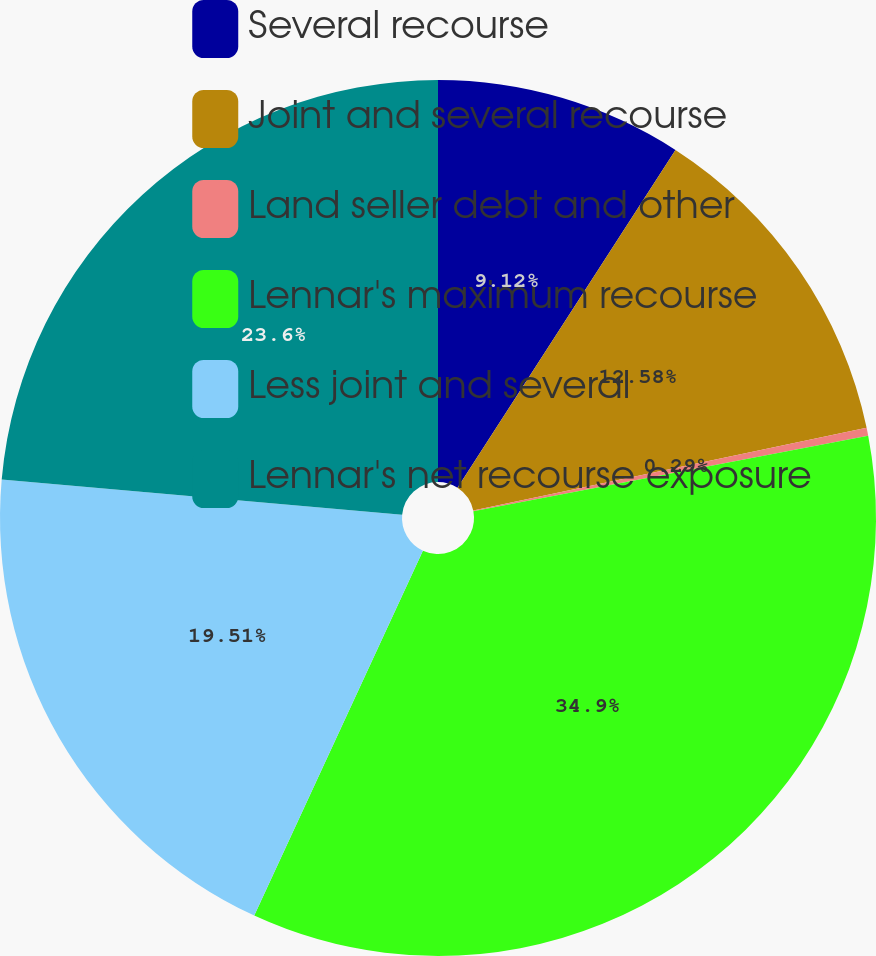Convert chart to OTSL. <chart><loc_0><loc_0><loc_500><loc_500><pie_chart><fcel>Several recourse<fcel>Joint and several recourse<fcel>Land seller debt and other<fcel>Lennar's maximum recourse<fcel>Less joint and several<fcel>Lennar's net recourse exposure<nl><fcel>9.12%<fcel>12.58%<fcel>0.29%<fcel>34.9%<fcel>19.51%<fcel>23.6%<nl></chart> 